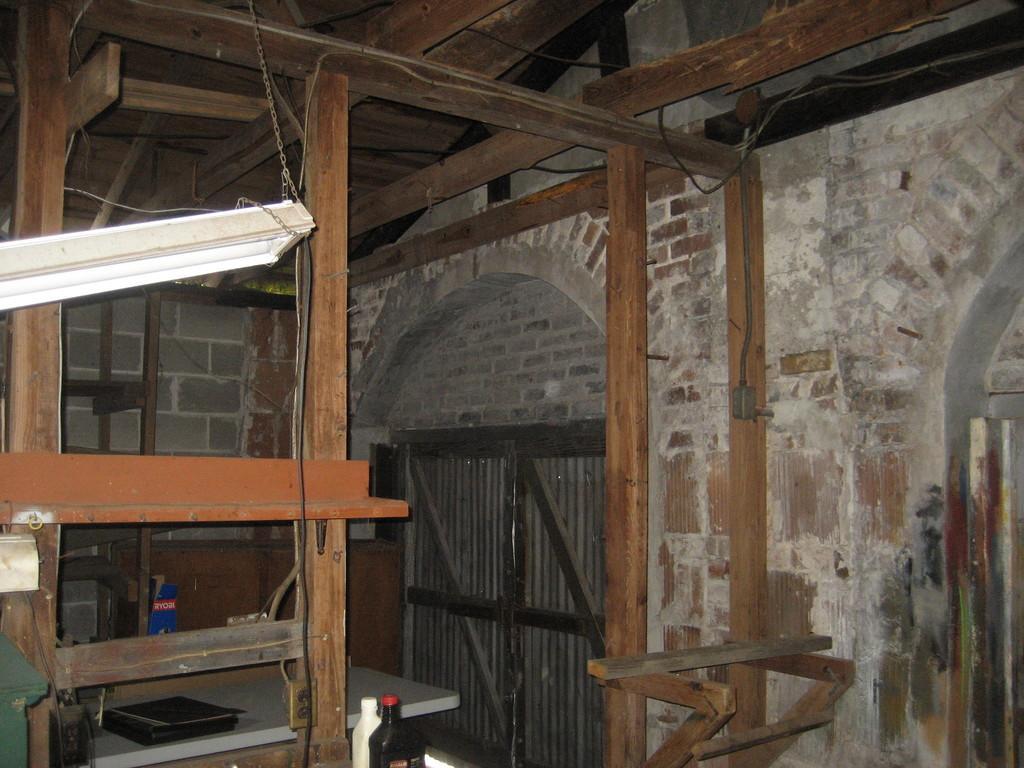Can you describe this image briefly? This is a table. On the table there are files. Here we can see bottles, and wood. In the background there is a wall and a door. 